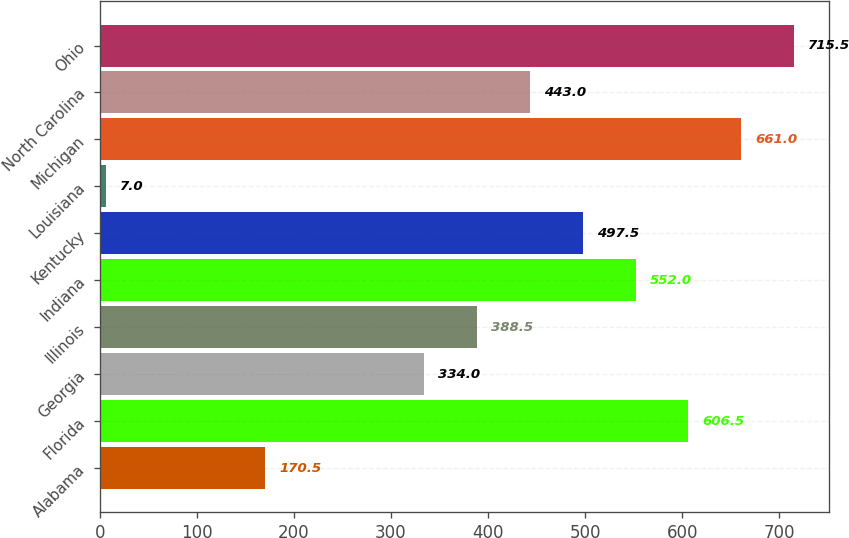Convert chart to OTSL. <chart><loc_0><loc_0><loc_500><loc_500><bar_chart><fcel>Alabama<fcel>Florida<fcel>Georgia<fcel>Illinois<fcel>Indiana<fcel>Kentucky<fcel>Louisiana<fcel>Michigan<fcel>North Carolina<fcel>Ohio<nl><fcel>170.5<fcel>606.5<fcel>334<fcel>388.5<fcel>552<fcel>497.5<fcel>7<fcel>661<fcel>443<fcel>715.5<nl></chart> 